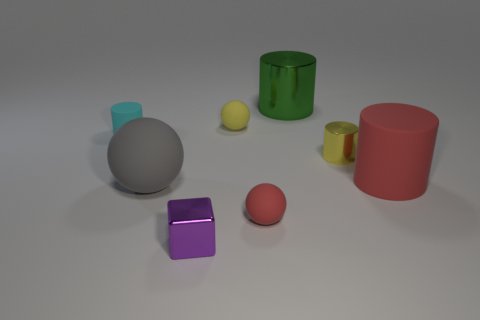There is a red object that is the same shape as the cyan thing; what is its material?
Provide a succinct answer. Rubber. How many cylinders are green things or cyan matte things?
Offer a terse response. 2. Do the ball in front of the gray matte thing and the red cylinder in front of the small yellow metallic cylinder have the same size?
Keep it short and to the point. No. There is a tiny cylinder left of the tiny red rubber sphere that is in front of the big green shiny thing; what is it made of?
Your response must be concise. Rubber. Are there fewer large red cylinders on the right side of the tiny cyan cylinder than tiny shiny things?
Offer a terse response. Yes. There is a small object that is made of the same material as the tiny yellow cylinder; what is its shape?
Offer a terse response. Cube. How many other objects are the same shape as the large green metallic thing?
Keep it short and to the point. 3. What number of brown objects are either large matte objects or small things?
Make the answer very short. 0. Does the cyan object have the same shape as the large metal thing?
Provide a succinct answer. Yes. Is there a yellow rubber object on the right side of the large rubber thing on the left side of the large green cylinder?
Your response must be concise. Yes. 